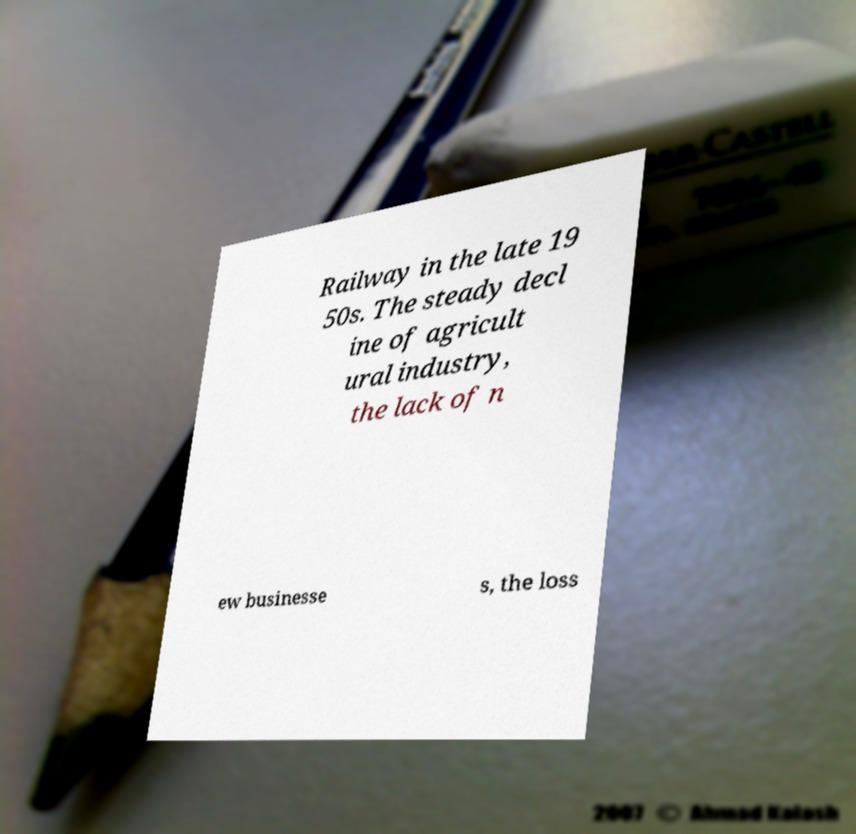Can you read and provide the text displayed in the image?This photo seems to have some interesting text. Can you extract and type it out for me? Railway in the late 19 50s. The steady decl ine of agricult ural industry, the lack of n ew businesse s, the loss 